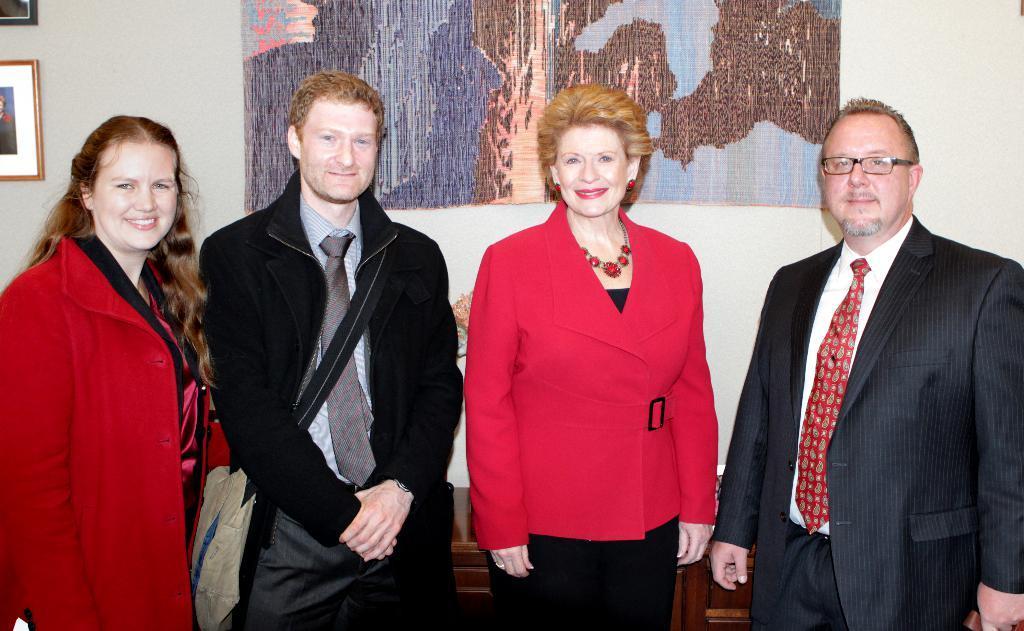Describe this image in one or two sentences. In this picture I can see four persons standing and smiling, and in the background there are frames attached to the wall. 